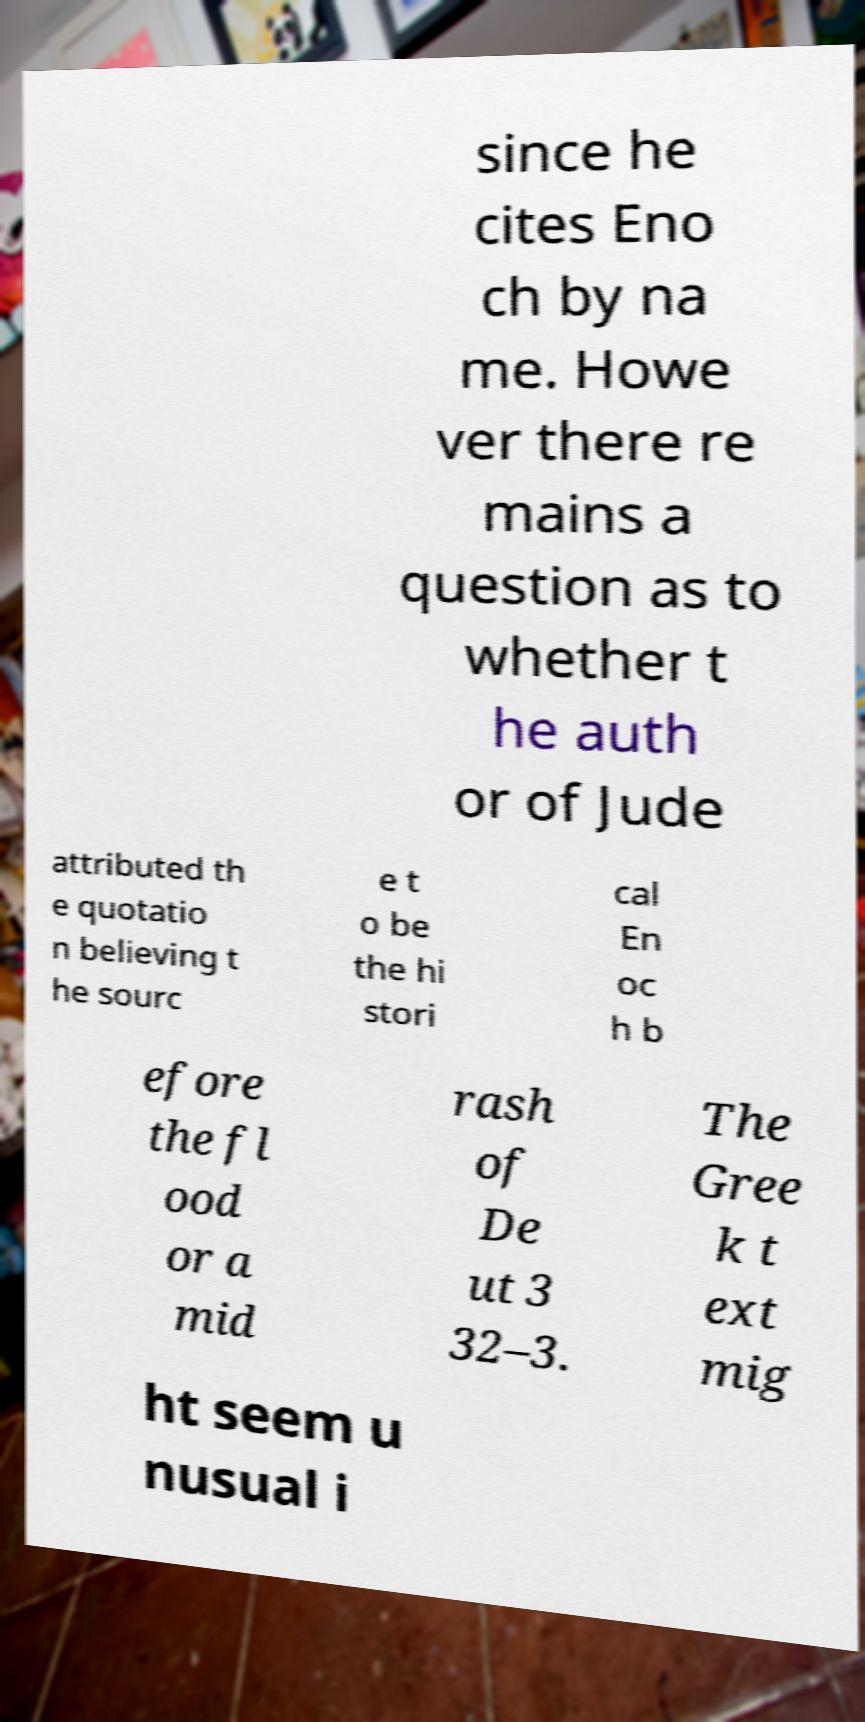For documentation purposes, I need the text within this image transcribed. Could you provide that? since he cites Eno ch by na me. Howe ver there re mains a question as to whether t he auth or of Jude attributed th e quotatio n believing t he sourc e t o be the hi stori cal En oc h b efore the fl ood or a mid rash of De ut 3 32–3. The Gree k t ext mig ht seem u nusual i 